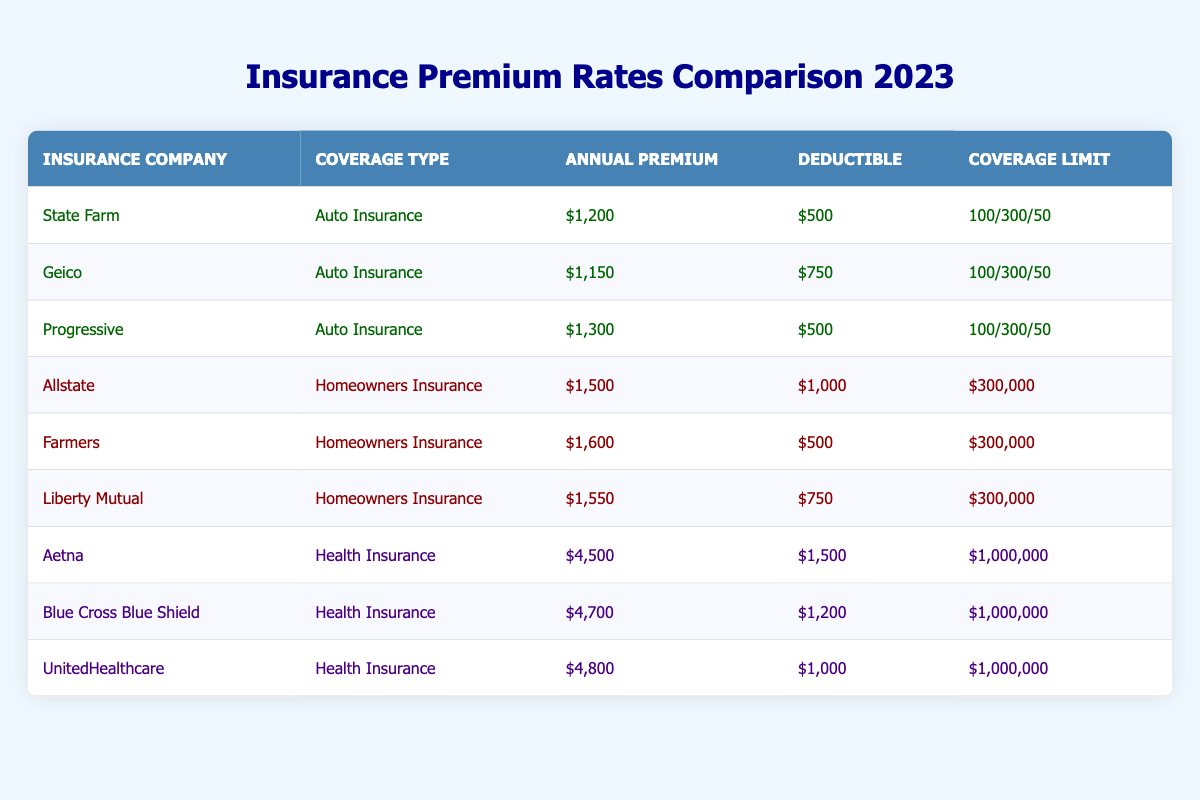What is the annual premium for State Farm's Auto Insurance? The table shows the annual premium for State Farm under the Auto Insurance coverage type as $1,200.
Answer: $1,200 Which homeowners insurance company has the lowest deductible? By reviewing the deductible amounts listed, Farmers has a deductible of $500, which is the lowest compared to Allstate ($1,000) and Liberty Mutual ($750).
Answer: Farmers What is the coverage limit for health insurance provided by Aetna? The coverage limit for Aetna in the health insurance category is denoted as $1,000,000.
Answer: $1,000,000 Is the annual premium for Blue Cross Blue Shield higher than that for Geico's Auto Insurance? The premium for Blue Cross Blue Shield is $4,700, while Geico charges $1,150 for Auto Insurance. Since $4,700 is greater than $1,150, the statement is true.
Answer: Yes What is the average annual premium cost for homeowners insurance from the companies listed? The total premiums for homeowners insurance are $1,500 (Allstate) + $1,600 (Farmers) + $1,550 (Liberty Mutual) = $4,650. There are 3 companies, so the average premium is $4,650 / 3 = $1,550.
Answer: $1,550 Which company has the highest annual premium for health insurance? A review of the health insurance premiums shows UnitedHealthcare at $4,800, which is the highest compared to Aetna ($4,500) and Blue Cross Blue Shield ($4,700).
Answer: UnitedHealthcare What is the difference between the highest and lowest annual premium for Auto Insurance? The highest premium for Auto Insurance is Progressive at $1,300, and the lowest is Geico at $1,150. The difference is $1,300 - $1,150 = $150.
Answer: $150 Does State Farm offer the lowest annual premium for Auto Insurance? The premium for State Farm's Auto Insurance is $1,200. Geico offers a lower premium of $1,150. Therefore, State Farm does not offer the lowest premium.
Answer: No What is the total annual premium for all health insurance policies listed? The total premiums for health insurance are $4,500 (Aetna) + $4,700 (Blue Cross Blue Shield) + $4,800 (UnitedHealthcare) = $14,000.
Answer: $14,000 